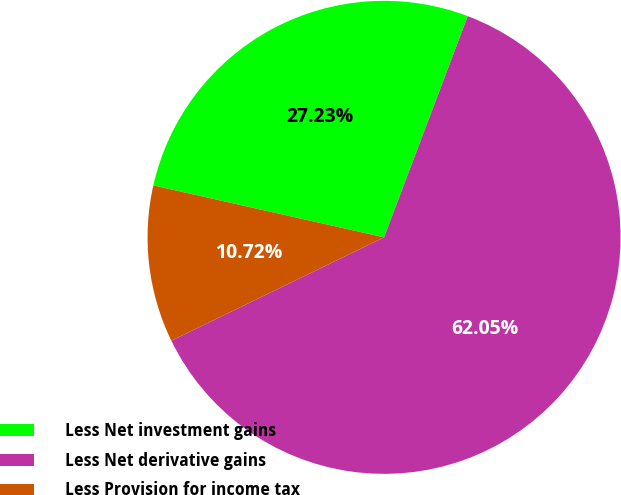Convert chart to OTSL. <chart><loc_0><loc_0><loc_500><loc_500><pie_chart><fcel>Less Net investment gains<fcel>Less Net derivative gains<fcel>Less Provision for income tax<nl><fcel>27.23%<fcel>62.04%<fcel>10.72%<nl></chart> 